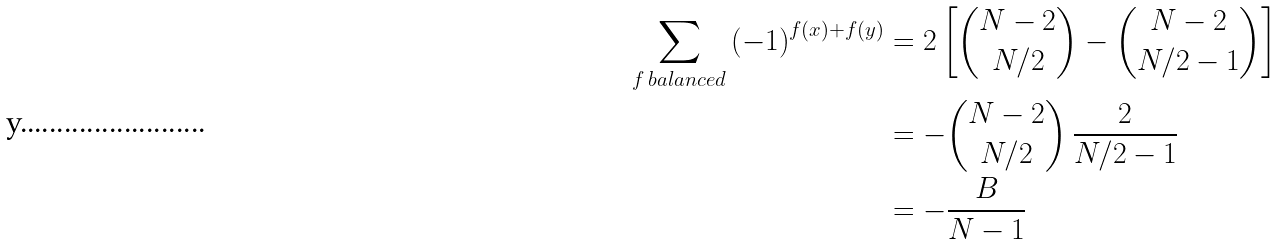Convert formula to latex. <formula><loc_0><loc_0><loc_500><loc_500>\sum _ { f \, b a l a n c e d } \left ( - 1 \right ) ^ { f ( x ) + f ( y ) } & = 2 \left [ \binom { N - 2 } { N / 2 } - \binom { N - 2 } { N / 2 - 1 } \right ] \\ & = - \binom { N - 2 } { N / 2 } \, \frac { 2 } { N / 2 - 1 } \\ & = - \frac { B } { N - 1 }</formula> 